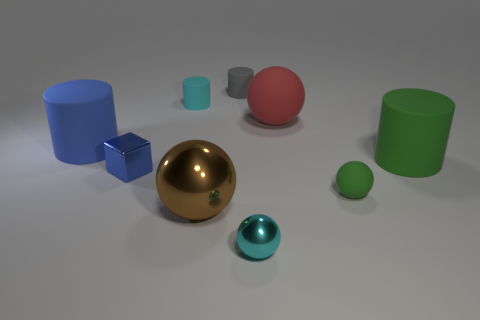There is a tiny rubber object that is both on the left side of the tiny green object and in front of the gray rubber thing; what is its color?
Offer a very short reply. Cyan. There is a tiny metallic object that is to the left of the cyan shiny ball; how many big shiny objects are on the left side of it?
Offer a terse response. 0. Do the gray object and the small blue shiny object have the same shape?
Make the answer very short. No. Are there any other things that have the same color as the tiny matte ball?
Offer a very short reply. Yes. There is a large metal object; does it have the same shape as the cyan object that is on the right side of the cyan matte object?
Your answer should be compact. Yes. What is the color of the matte cylinder on the right side of the green thing left of the thing that is on the right side of the green rubber sphere?
Make the answer very short. Green. There is a tiny cyan object in front of the big blue thing; is it the same shape as the large red object?
Make the answer very short. Yes. What is the blue cylinder made of?
Ensure brevity in your answer.  Rubber. There is a big thing that is right of the sphere that is behind the large cylinder that is to the left of the large green object; what shape is it?
Offer a very short reply. Cylinder. How many other objects are there of the same shape as the large brown metal thing?
Your answer should be compact. 3. 